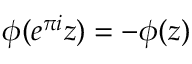Convert formula to latex. <formula><loc_0><loc_0><loc_500><loc_500>\phi ( e ^ { \pi i } z ) = - \phi ( z )</formula> 